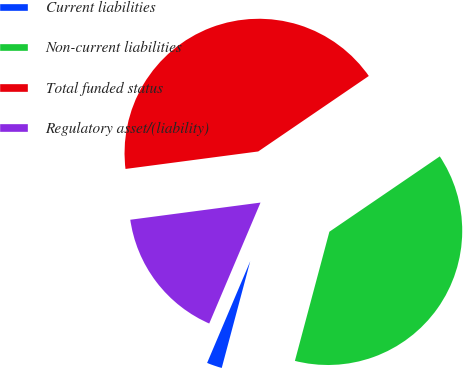<chart> <loc_0><loc_0><loc_500><loc_500><pie_chart><fcel>Current liabilities<fcel>Non-current liabilities<fcel>Total funded status<fcel>Regulatory asset/(liability)<nl><fcel>2.23%<fcel>38.68%<fcel>42.55%<fcel>16.53%<nl></chart> 